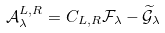Convert formula to latex. <formula><loc_0><loc_0><loc_500><loc_500>\mathcal { A } _ { \lambda } ^ { L , R } = C _ { L , R } \mathcal { F } _ { \lambda } - \widetilde { \mathcal { G } } _ { \lambda }</formula> 